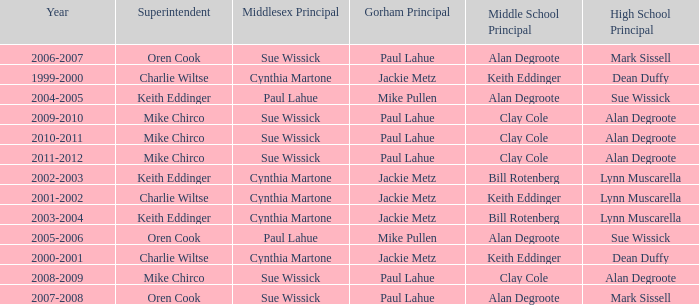How many years was lynn muscarella the high school principal and charlie wiltse the superintendent? 1.0. 